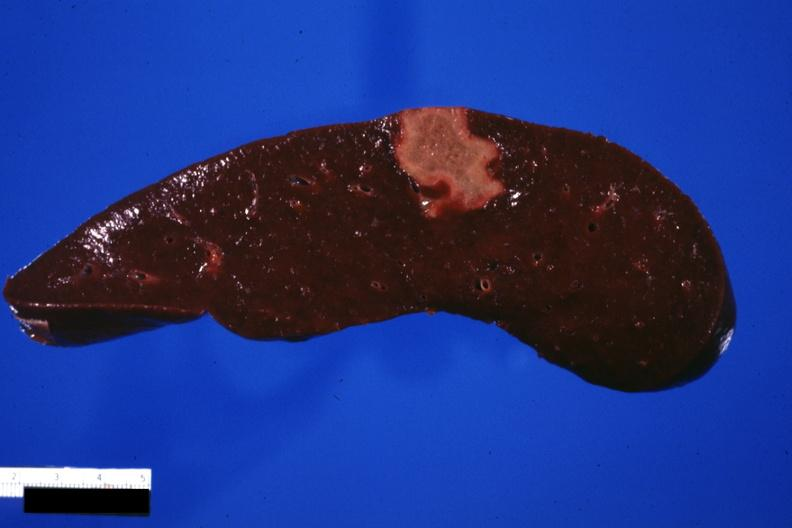s a bulge present?
Answer the question using a single word or phrase. No 